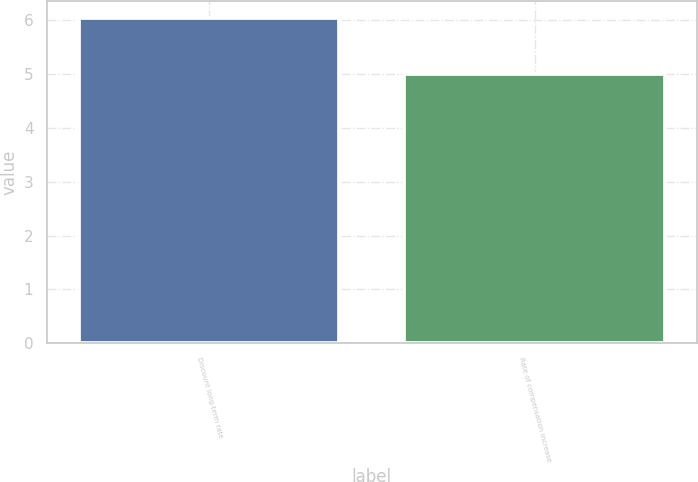Convert chart to OTSL. <chart><loc_0><loc_0><loc_500><loc_500><bar_chart><fcel>Discount long-term rate<fcel>Rate of compensation increase<nl><fcel>6.05<fcel>5<nl></chart> 